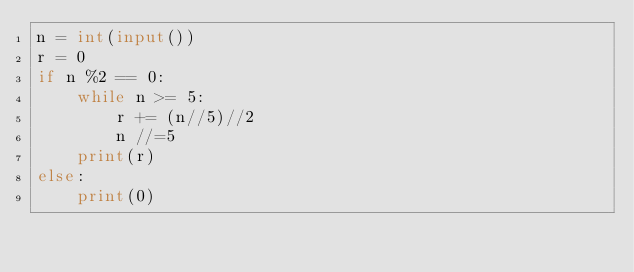<code> <loc_0><loc_0><loc_500><loc_500><_Python_>n = int(input())
r = 0
if n %2 == 0:
    while n >= 5:
        r += (n//5)//2
        n //=5
    print(r)
else:
    print(0)</code> 